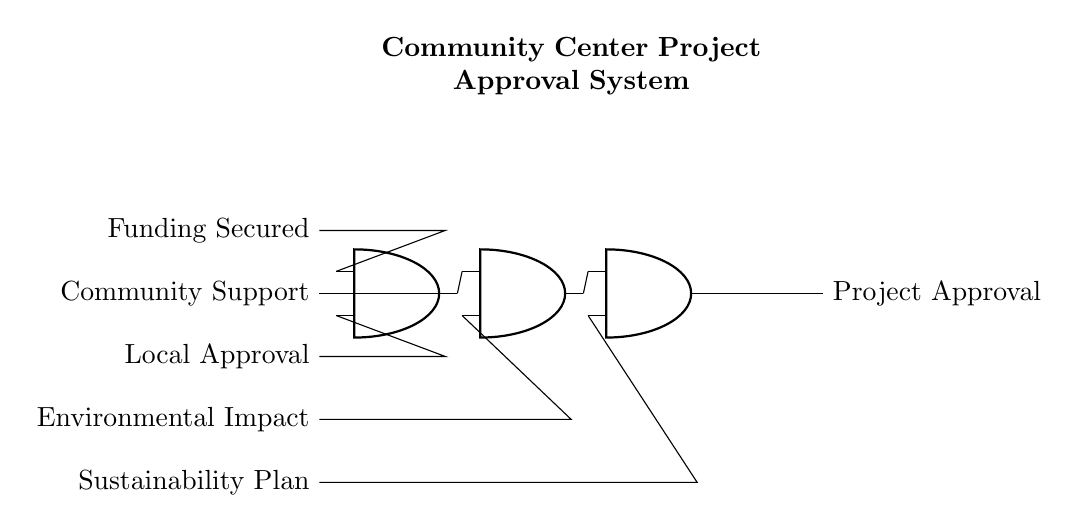What is the final output of the circuit? The final output is Project Approval, which is shown at the end of the circuit diagram. It indicates the successful culmination of the approval process based on the preceding criteria.
Answer: Project Approval How many AND gates are used in the circuit? There are three AND gates shown in the circuit diagram, each contributing to the approval process by requiring multiple inputs.
Answer: Three What are the first two criteria required for the project approval? The first two criteria listed are Community Support and Funding Secured, which are the inputs to the first AND gate in the sequence.
Answer: Community Support and Funding Secured What does the second AND gate integrate? The second AND gate integrates the output from the first AND gate and the Environmental Impact criterion, allowing for more comprehensive decision-making.
Answer: Output from the first gate and Environmental Impact If one criterion fails, what is the outcome? If one criterion fails, the outcome will be that the final output, Project Approval, will not be achieved, as all inputs to the AND gates must be valid for the output to be successful.
Answer: No approval What is the significance of the Sustainability Plan in the circuit? The Sustainability Plan is the last criterion processed by the third AND gate, ensuring that all preceding criteria are met before project approval is granted.
Answer: Final criterion for approval 